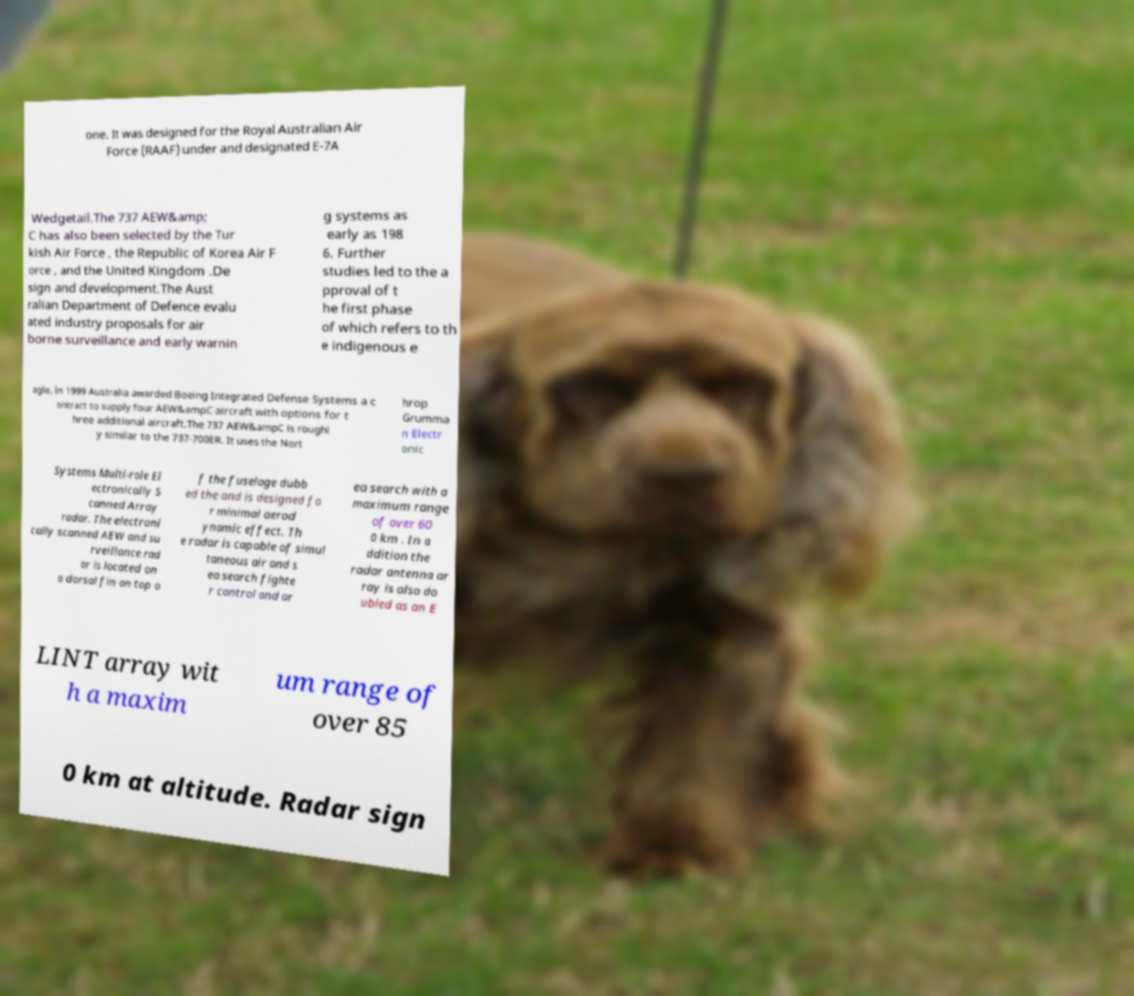For documentation purposes, I need the text within this image transcribed. Could you provide that? one. It was designed for the Royal Australian Air Force (RAAF) under and designated E-7A Wedgetail.The 737 AEW&amp; C has also been selected by the Tur kish Air Force , the Republic of Korea Air F orce , and the United Kingdom .De sign and development.The Aust ralian Department of Defence evalu ated industry proposals for air borne surveillance and early warnin g systems as early as 198 6. Further studies led to the a pproval of t he first phase of which refers to th e indigenous e agle. In 1999 Australia awarded Boeing Integrated Defense Systems a c ontract to supply four AEW&ampC aircraft with options for t hree additional aircraft.The 737 AEW&ampC is roughl y similar to the 737-700ER. It uses the Nort hrop Grumma n Electr onic Systems Multi-role El ectronically S canned Array radar. The electroni cally scanned AEW and su rveillance rad ar is located on a dorsal fin on top o f the fuselage dubb ed the and is designed fo r minimal aerod ynamic effect. Th e radar is capable of simul taneous air and s ea search fighte r control and ar ea search with a maximum range of over 60 0 km . In a ddition the radar antenna ar ray is also do ubled as an E LINT array wit h a maxim um range of over 85 0 km at altitude. Radar sign 